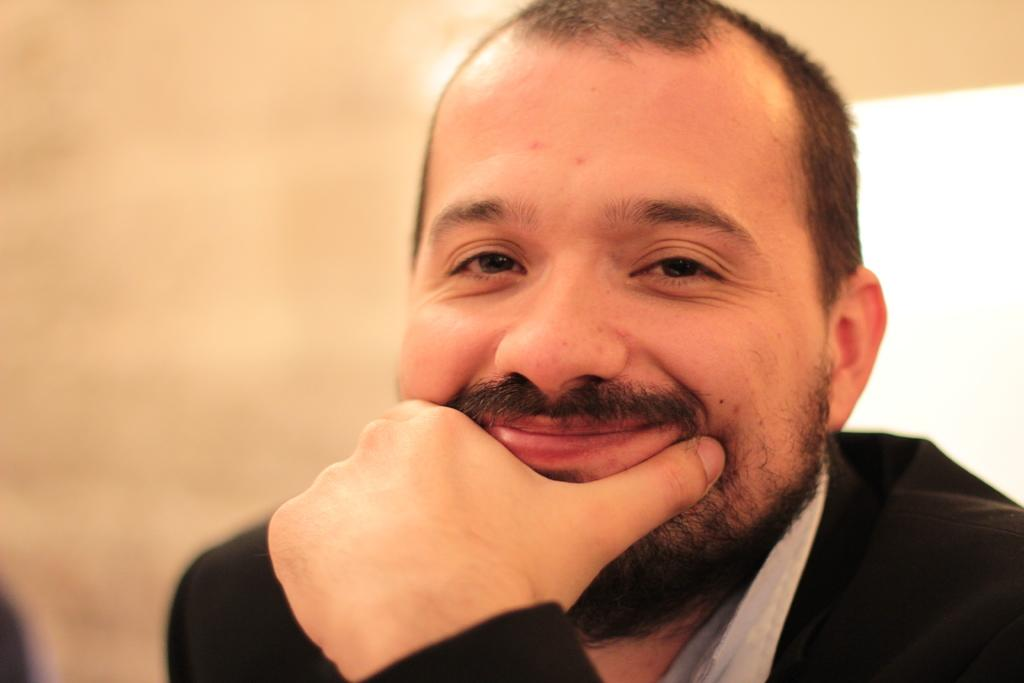Who is present in the image? There is a man in the image. What is the man doing in the image? The man is smiling in the image. Can you describe the background of the image? The background of the image is blurred. What type of curve can be seen on the wall in the image? There is no wall or curve present in the image; it features a man smiling with a blurred background. 